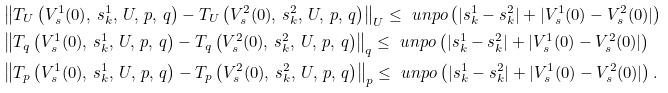<formula> <loc_0><loc_0><loc_500><loc_500>& \left \| T _ { U } \left ( V ^ { 1 } _ { s } ( 0 ) , \, s ^ { 1 } _ { k } , \, U , \, p , \, q \right ) - T _ { U } \left ( V ^ { 2 } _ { s } ( 0 ) , \, s ^ { 2 } _ { k } , \, U , \, p , \, q \right ) \right \| _ { U } \leq \ u n p o \left ( | s ^ { 1 } _ { k } - s ^ { 2 } _ { k } | + | V ^ { 1 } _ { s } ( 0 ) - V ^ { 2 } _ { s } ( 0 ) | \right ) \\ & \left \| T _ { q } \left ( V ^ { 1 } _ { s } ( 0 ) , \, s ^ { 1 } _ { k } , \, U , \, p , \, q \right ) - T _ { q } \left ( V ^ { 2 } _ { s } ( 0 ) , \, s ^ { 2 } _ { k } , \, U , \, p , \, q \right ) \right \| _ { q } \leq \ u n p o \left ( | s ^ { 1 } _ { k } - s ^ { 2 } _ { k } | + | V ^ { 1 } _ { s } ( 0 ) - V ^ { 2 } _ { s } ( 0 ) | \right ) \\ & \left \| T _ { p } \left ( V ^ { 1 } _ { s } ( 0 ) , \, s ^ { 1 } _ { k } , \, U , \, p , \, q \right ) - T _ { p } \left ( V ^ { 2 } _ { s } ( 0 ) , \, s ^ { 2 } _ { k } , \, U , \, p , \, q \right ) \right \| _ { p } \leq \ u n p o \left ( | s ^ { 1 } _ { k } - s ^ { 2 } _ { k } | + | V ^ { 1 } _ { s } ( 0 ) - V ^ { 2 } _ { s } ( 0 ) | \right ) .</formula> 